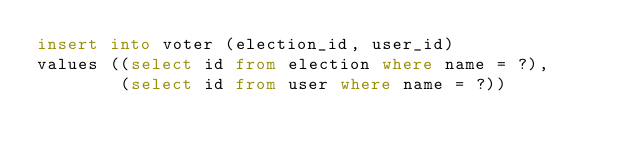<code> <loc_0><loc_0><loc_500><loc_500><_SQL_>insert into voter (election_id, user_id)
values ((select id from election where name = ?),
        (select id from user where name = ?))
</code> 